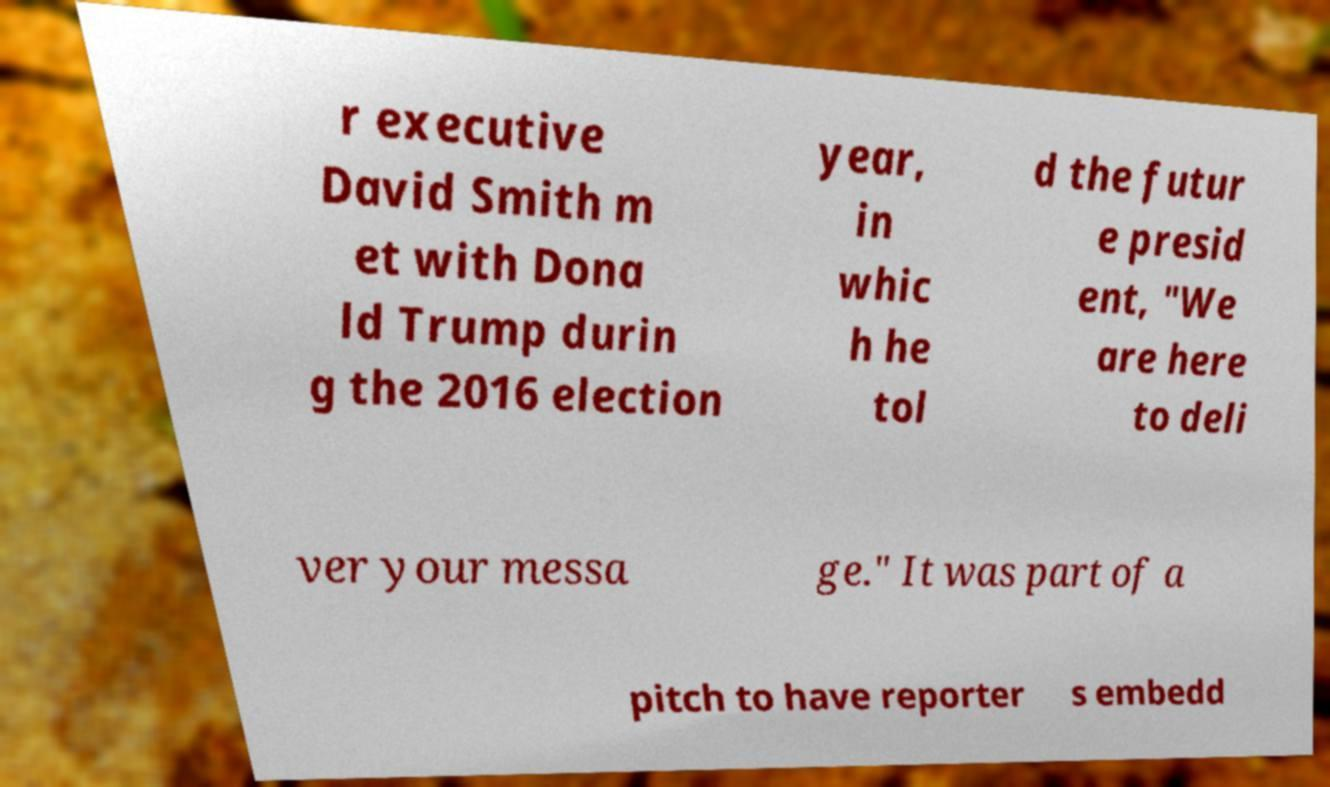For documentation purposes, I need the text within this image transcribed. Could you provide that? r executive David Smith m et with Dona ld Trump durin g the 2016 election year, in whic h he tol d the futur e presid ent, "We are here to deli ver your messa ge." It was part of a pitch to have reporter s embedd 